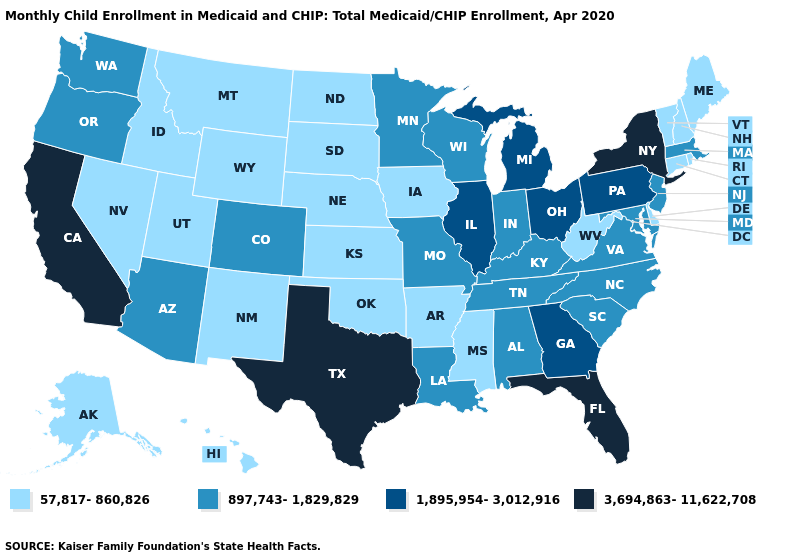Which states have the lowest value in the South?
Give a very brief answer. Arkansas, Delaware, Mississippi, Oklahoma, West Virginia. What is the value of New Mexico?
Keep it brief. 57,817-860,826. Does Alabama have the lowest value in the South?
Concise answer only. No. Name the states that have a value in the range 897,743-1,829,829?
Keep it brief. Alabama, Arizona, Colorado, Indiana, Kentucky, Louisiana, Maryland, Massachusetts, Minnesota, Missouri, New Jersey, North Carolina, Oregon, South Carolina, Tennessee, Virginia, Washington, Wisconsin. Does the first symbol in the legend represent the smallest category?
Concise answer only. Yes. Name the states that have a value in the range 3,694,863-11,622,708?
Answer briefly. California, Florida, New York, Texas. Name the states that have a value in the range 3,694,863-11,622,708?
Short answer required. California, Florida, New York, Texas. Which states have the lowest value in the USA?
Quick response, please. Alaska, Arkansas, Connecticut, Delaware, Hawaii, Idaho, Iowa, Kansas, Maine, Mississippi, Montana, Nebraska, Nevada, New Hampshire, New Mexico, North Dakota, Oklahoma, Rhode Island, South Dakota, Utah, Vermont, West Virginia, Wyoming. Among the states that border Nebraska , does Missouri have the lowest value?
Short answer required. No. What is the value of Wisconsin?
Answer briefly. 897,743-1,829,829. Among the states that border Tennessee , which have the lowest value?
Keep it brief. Arkansas, Mississippi. What is the value of New York?
Quick response, please. 3,694,863-11,622,708. What is the value of South Carolina?
Concise answer only. 897,743-1,829,829. What is the value of Georgia?
Concise answer only. 1,895,954-3,012,916. Does Louisiana have the lowest value in the USA?
Short answer required. No. 